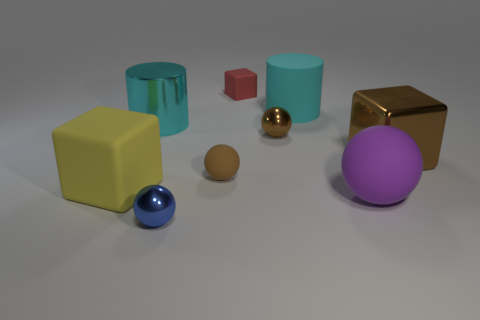Add 1 red rubber blocks. How many objects exist? 10 Subtract all cubes. How many objects are left? 6 Subtract 0 cyan blocks. How many objects are left? 9 Subtract all green matte objects. Subtract all tiny red matte blocks. How many objects are left? 8 Add 8 small metallic balls. How many small metallic balls are left? 10 Add 1 large brown objects. How many large brown objects exist? 2 